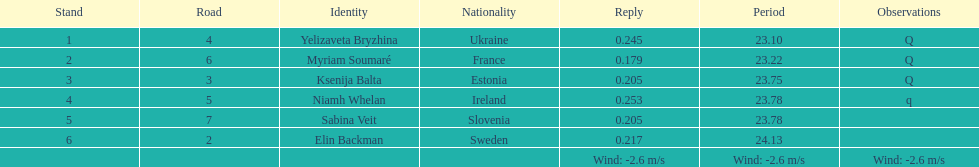Who finished after sabina veit? Elin Backman. Could you help me parse every detail presented in this table? {'header': ['Stand', 'Road', 'Identity', 'Nationality', 'Reply', 'Period', 'Observations'], 'rows': [['1', '4', 'Yelizaveta Bryzhina', 'Ukraine', '0.245', '23.10', 'Q'], ['2', '6', 'Myriam Soumaré', 'France', '0.179', '23.22', 'Q'], ['3', '3', 'Ksenija Balta', 'Estonia', '0.205', '23.75', 'Q'], ['4', '5', 'Niamh Whelan', 'Ireland', '0.253', '23.78', 'q'], ['5', '7', 'Sabina Veit', 'Slovenia', '0.205', '23.78', ''], ['6', '2', 'Elin Backman', 'Sweden', '0.217', '24.13', ''], ['', '', '', '', 'Wind: -2.6\xa0m/s', 'Wind: -2.6\xa0m/s', 'Wind: -2.6\xa0m/s']]} 